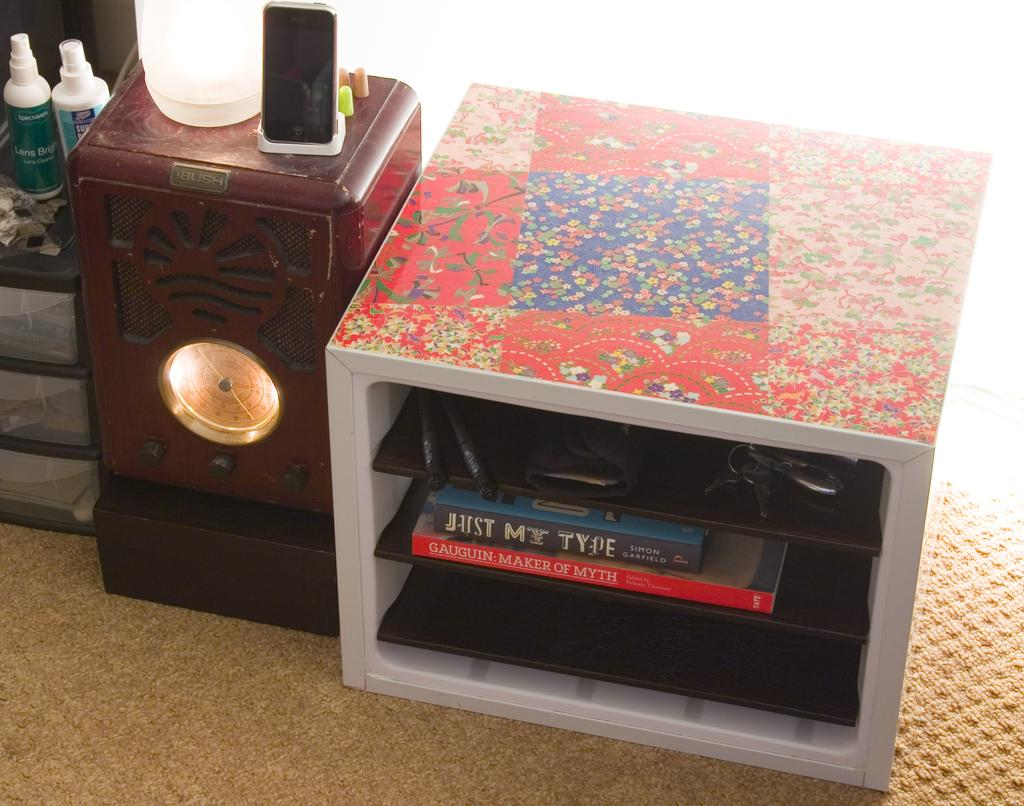<image>
Render a clear and concise summary of the photo. A book titled Just my type inside a bookcase. 